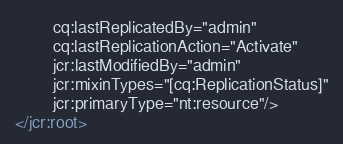Convert code to text. <code><loc_0><loc_0><loc_500><loc_500><_XML_>        cq:lastReplicatedBy="admin"
        cq:lastReplicationAction="Activate"
        jcr:lastModifiedBy="admin"
        jcr:mixinTypes="[cq:ReplicationStatus]"
        jcr:primaryType="nt:resource"/>
</jcr:root>
</code> 